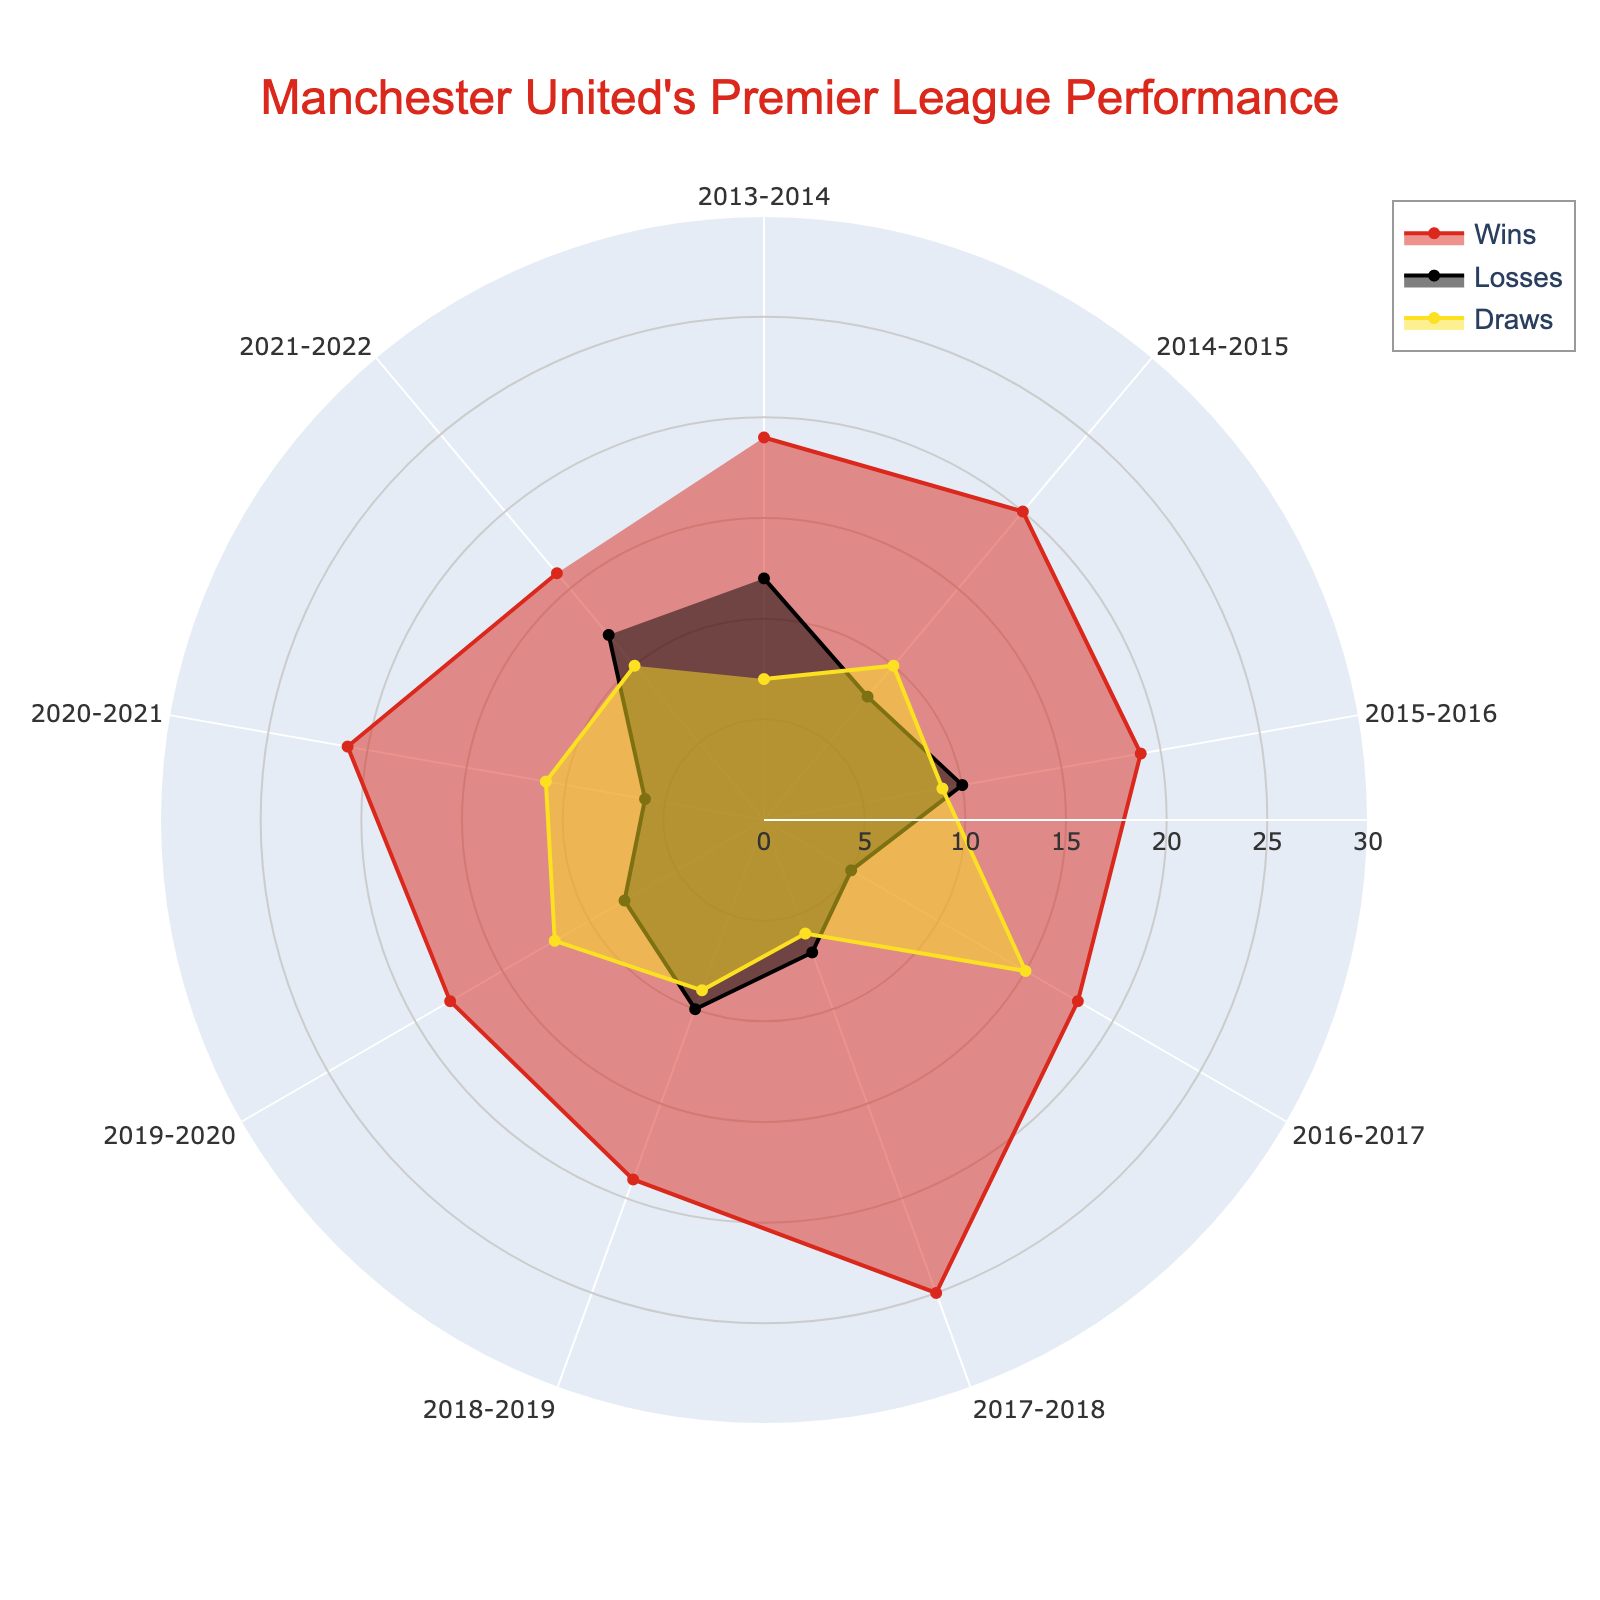Which season had the most wins? Compare the heights (distance from the center) of the 'Wins' lines for each season. The tallest one represents the highest number of wins.
Answer: 2017-2018 Which season had the least number of losses? Look at the 'Losses' lines for each season and find the shortest one.
Answer: 2016-2017 How many wins did Manchester United have in the 2014-2015 season? Find the data point on the 'Wins' line corresponding to the 2014-2015 season.
Answer: 20 What is the average number of draws across all seasons? Sum the number of draws for each season and divide by the number of seasons (7+10+9+15+6+9+12+11+10)/9.
Answer: 9.9 Which season had an equal number of wins and losses? Look for the season(s) where the 'Wins' and 'Losses' lines are at the same height.
Answer: None How many total matches did Manchester United play in the 2016-2017 season? Add the number of wins, losses, and draws for the 2016-2017 season (18+5+15).
Answer: 38 Which season saw the highest variation between wins and losses? Calculate the difference between wins and losses for each season and identify the one with the maximum value (2017-2018, with 25 wins and 7 losses).
Answer: 18 (2017-2018) Between the 2018-2019 and 2019-2020 seasons, which had more draws? Compare the heights of the 'Draws' lines for these two seasons.
Answer: 2019-2020 How did the number of losses change from the 2013-2014 season to the 2014-2015 season? Compare the heights of the 'Losses' lines for the 2013-2014 and 2014-2015 seasons (12 losses in 2013-2014, 8 losses in 2014-2015).
Answer: Decreased by 4 Which season had the highest number of draws, and how many were there? Look for the tallest 'Draws' line and note its season and height.
Answer: 2016-2017, with 15 draws 